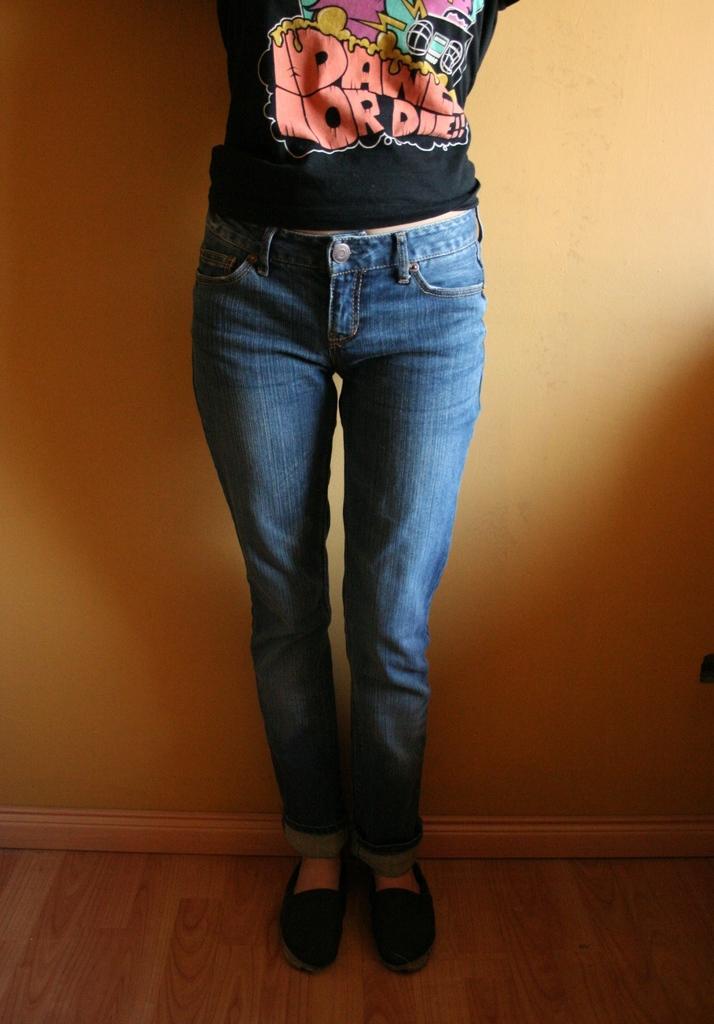Can you describe this image briefly? In this picture I can see a human and I can see a wall in the background. 